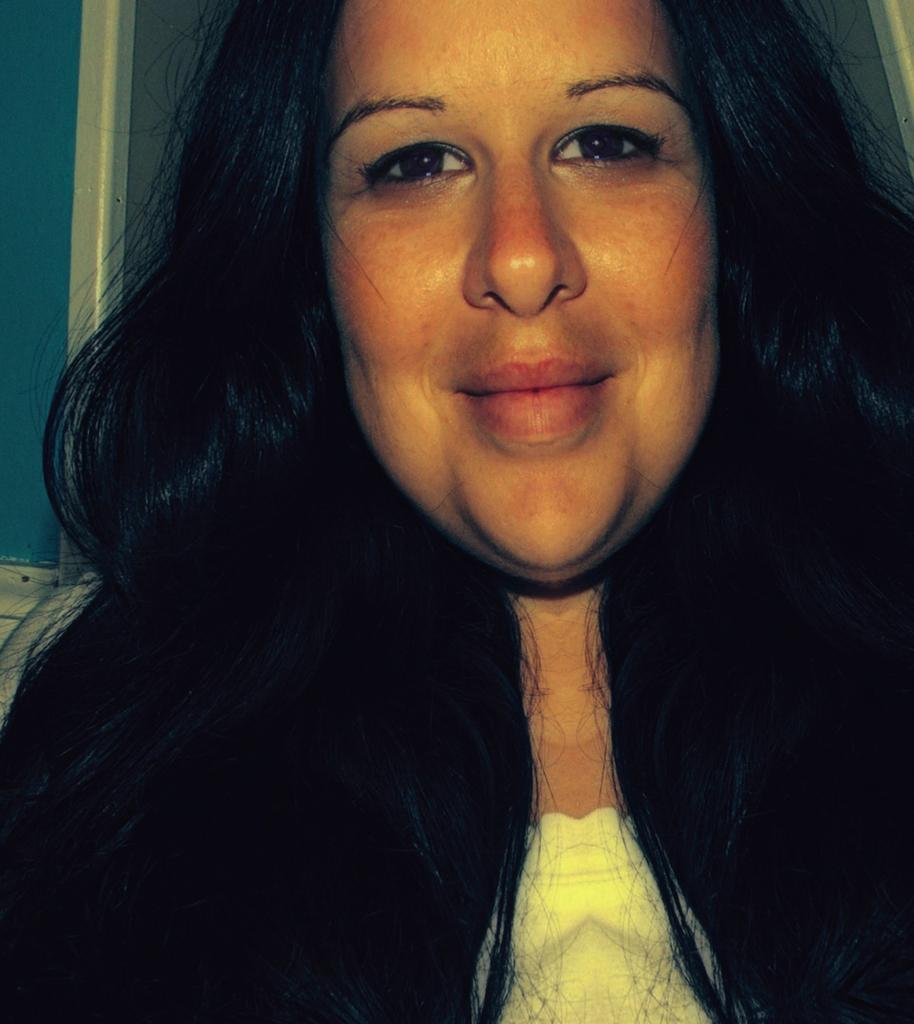Who is present in the image? There is a woman in the image. What expression does the woman have? The woman is smiling. What type of vegetable is the woman holding in the image? There is no vegetable present in the image; the woman is not holding anything. 